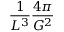Convert formula to latex. <formula><loc_0><loc_0><loc_500><loc_500>\frac { 1 } { L ^ { 3 } } \frac { 4 \pi } { G ^ { 2 } }</formula> 